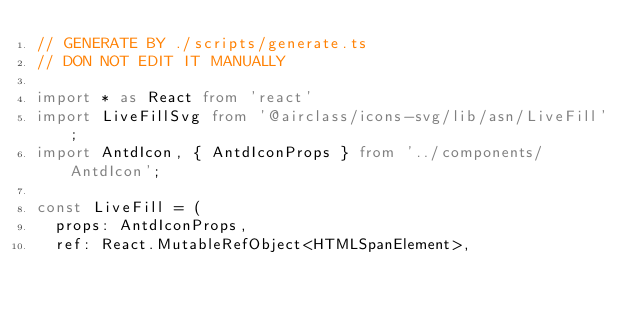<code> <loc_0><loc_0><loc_500><loc_500><_TypeScript_>// GENERATE BY ./scripts/generate.ts
// DON NOT EDIT IT MANUALLY

import * as React from 'react'
import LiveFillSvg from '@airclass/icons-svg/lib/asn/LiveFill';
import AntdIcon, { AntdIconProps } from '../components/AntdIcon';

const LiveFill = (
  props: AntdIconProps,
  ref: React.MutableRefObject<HTMLSpanElement>,</code> 